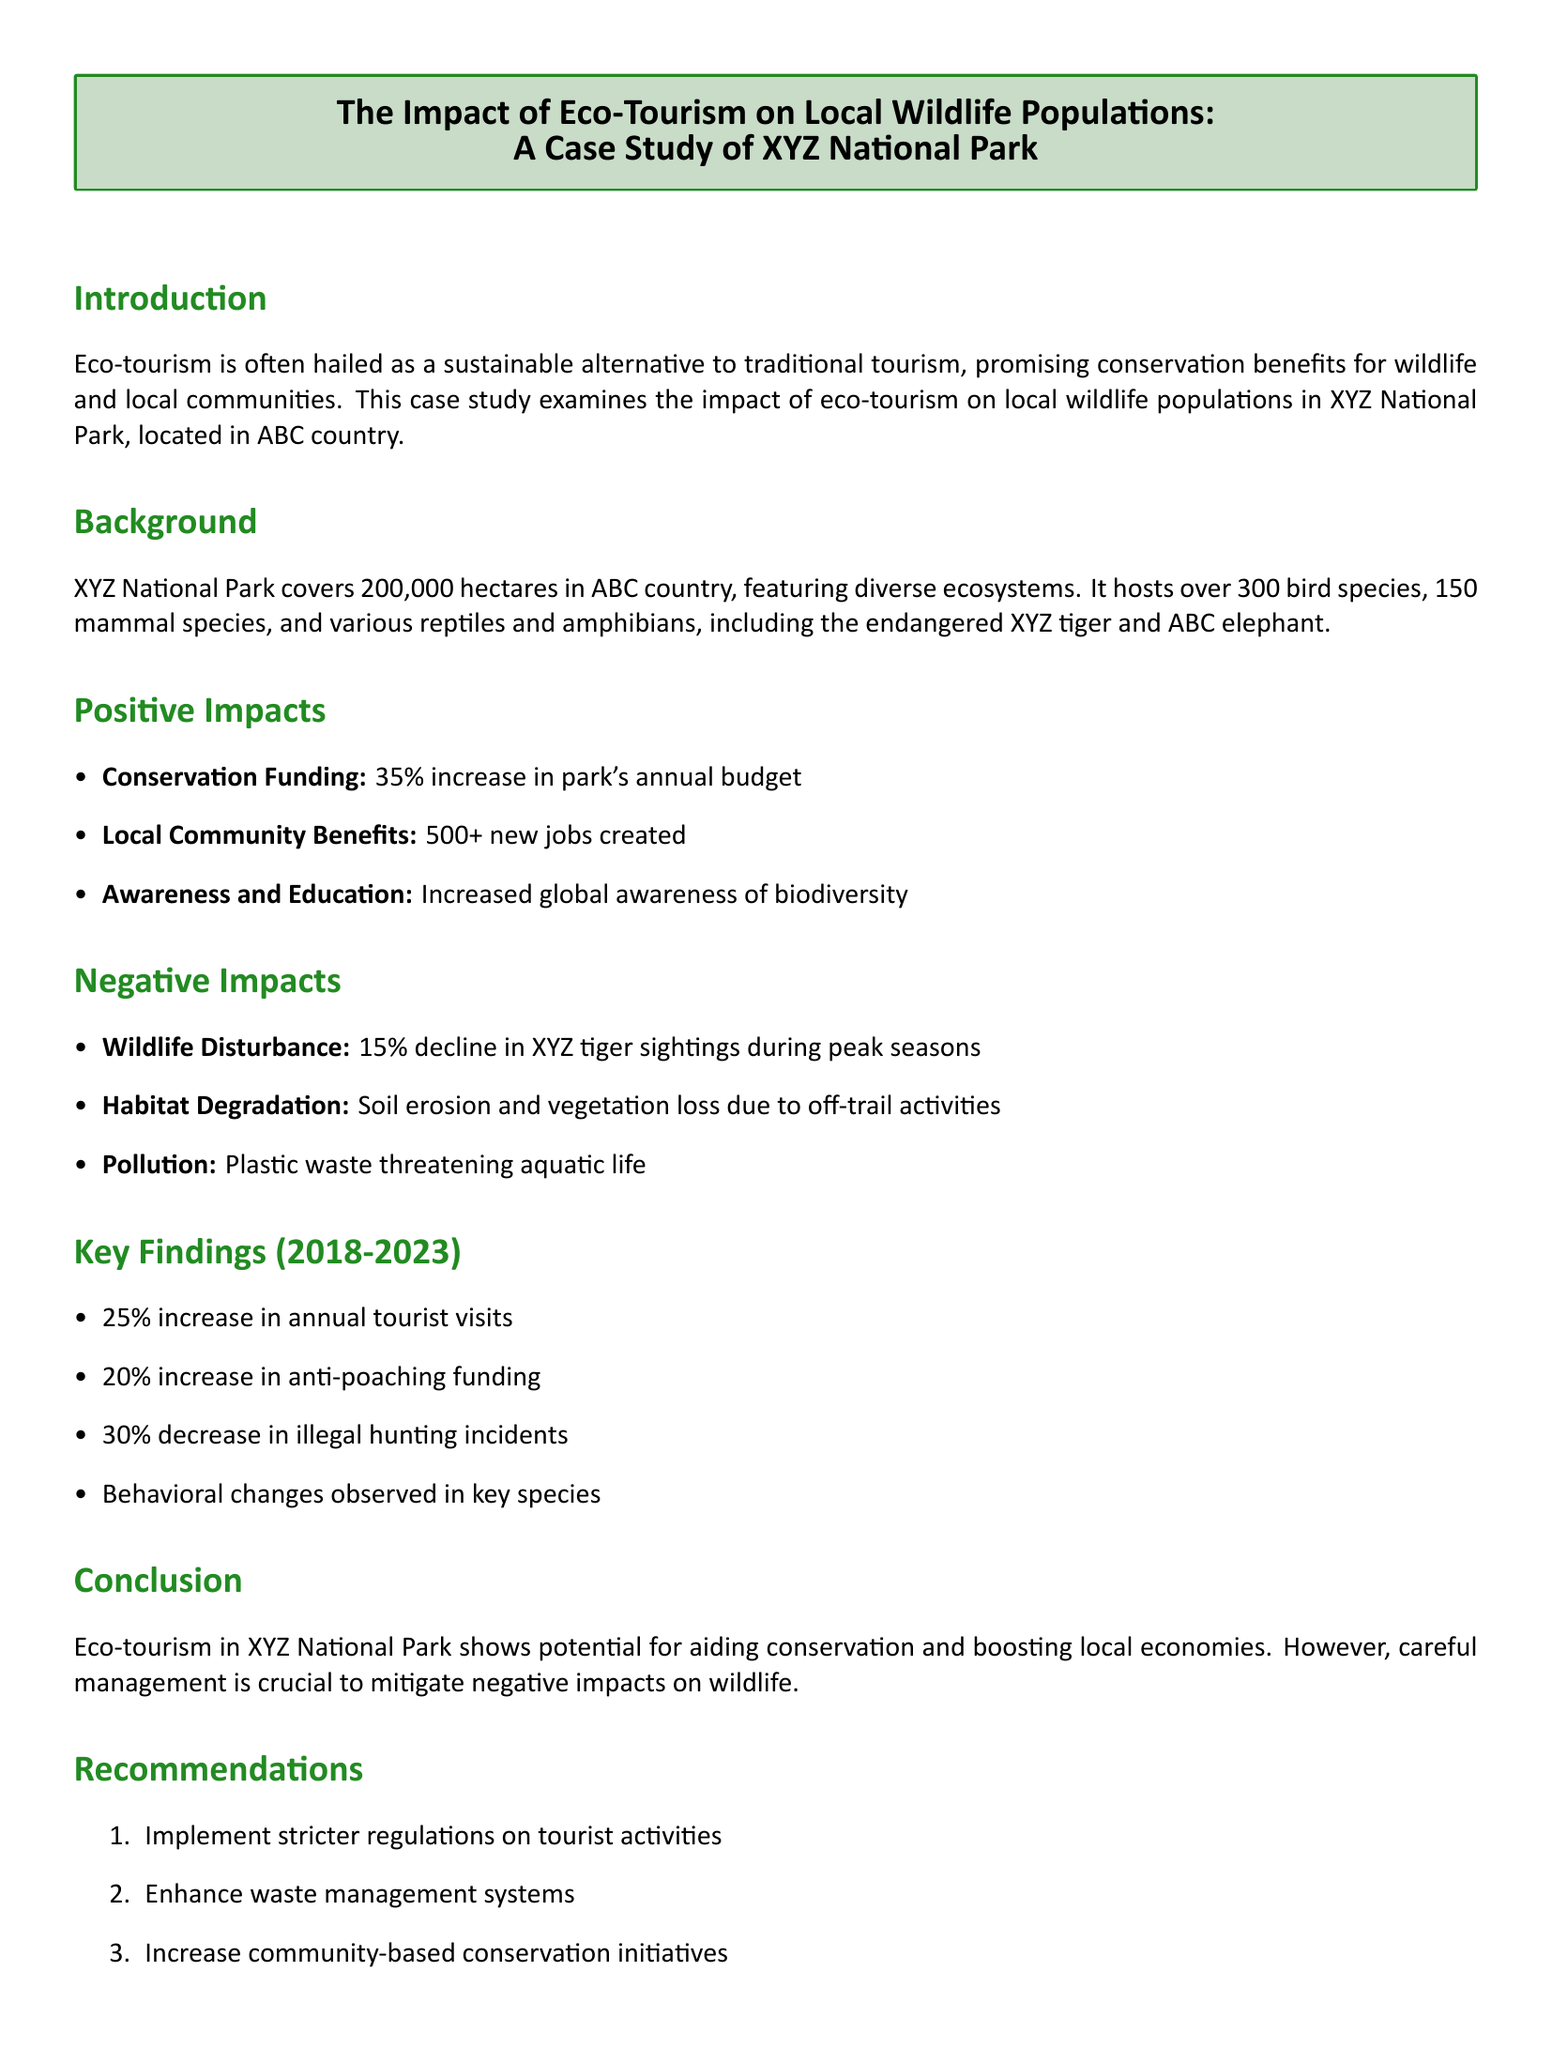What is the area of XYZ National Park? The area of XYZ National Park is specified in the background section of the document as 200,000 hectares.
Answer: 200,000 hectares How many bird species are hosted in XYZ National Park? The number of bird species is mentioned in the background section as over 300.
Answer: Over 300 What was the percentage increase in the park's annual budget? The positive impacts section states that there was a 35% increase in the park's annual budget due to eco-tourism.
Answer: 35% What percentage decline in XYZ tiger sightings was reported? The negative impacts section indicates a 15% decline in XYZ tiger sightings during peak seasons.
Answer: 15% What is the percentage increase in annual tourist visits from 2018-2023? The key findings section notes a 25% increase in annual tourist visits during this period.
Answer: 25% What type of waste is threatening aquatic life? The document mentions plastic waste as a threat to aquatic life in the negative impacts section.
Answer: Plastic waste What recommendation is related to tourist activity management? In the recommendations section, the first recommendation is to implement stricter regulations on tourist activities.
Answer: Stricter regulations How much did anti-poaching funding increase by? The key findings section indicates a 20% increase in anti-poaching funding from 2018-2023.
Answer: 20% 